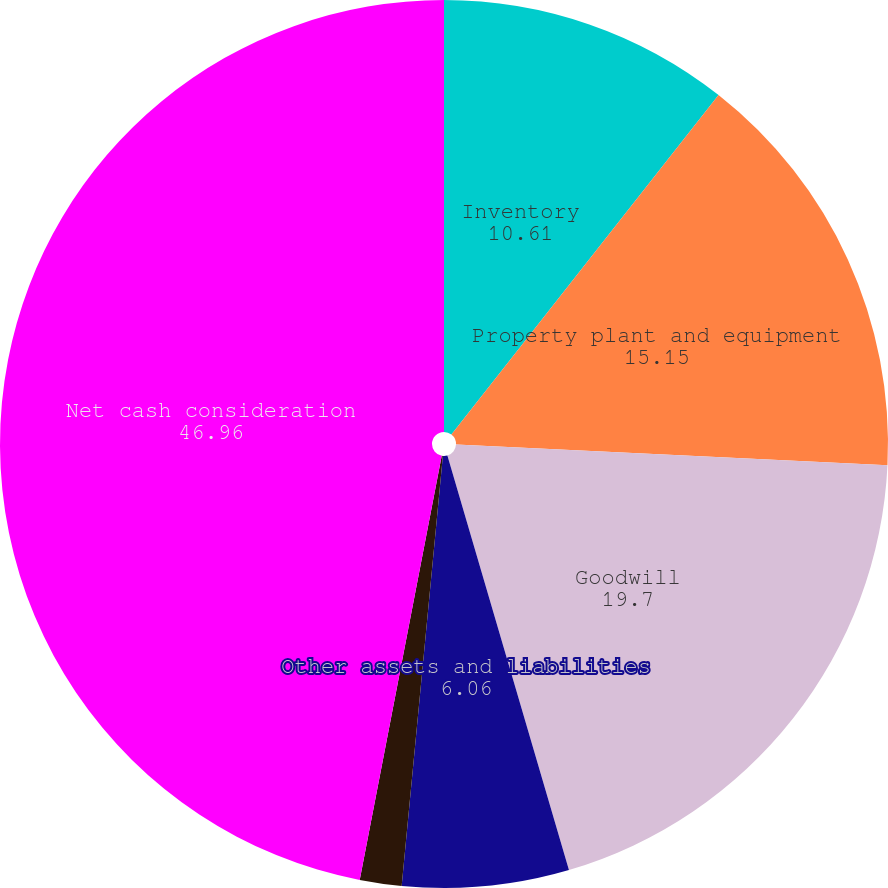Convert chart. <chart><loc_0><loc_0><loc_500><loc_500><pie_chart><fcel>Inventory<fcel>Property plant and equipment<fcel>Goodwill<fcel>Other assets and liabilities<fcel>Additional consideration for<fcel>Net cash consideration<nl><fcel>10.61%<fcel>15.15%<fcel>19.7%<fcel>6.06%<fcel>1.52%<fcel>46.96%<nl></chart> 